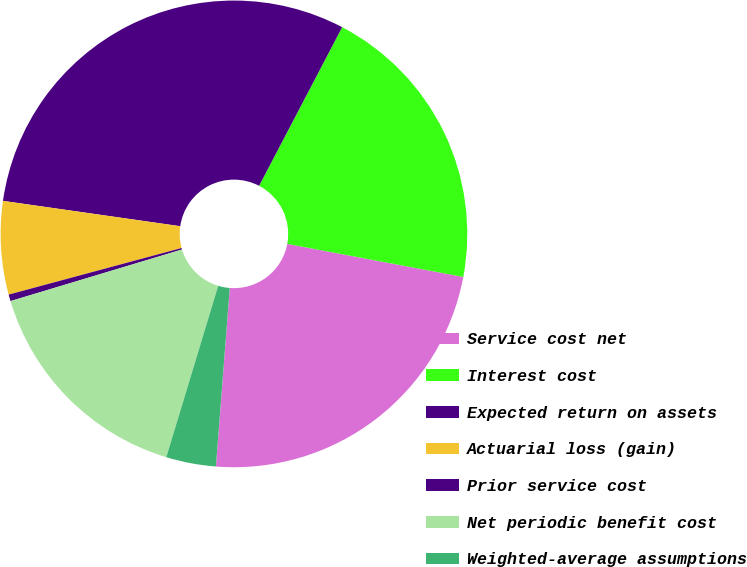<chart> <loc_0><loc_0><loc_500><loc_500><pie_chart><fcel>Service cost net<fcel>Interest cost<fcel>Expected return on assets<fcel>Actuarial loss (gain)<fcel>Prior service cost<fcel>Net periodic benefit cost<fcel>Weighted-average assumptions<nl><fcel>23.28%<fcel>20.28%<fcel>30.42%<fcel>6.45%<fcel>0.46%<fcel>15.67%<fcel>3.45%<nl></chart> 